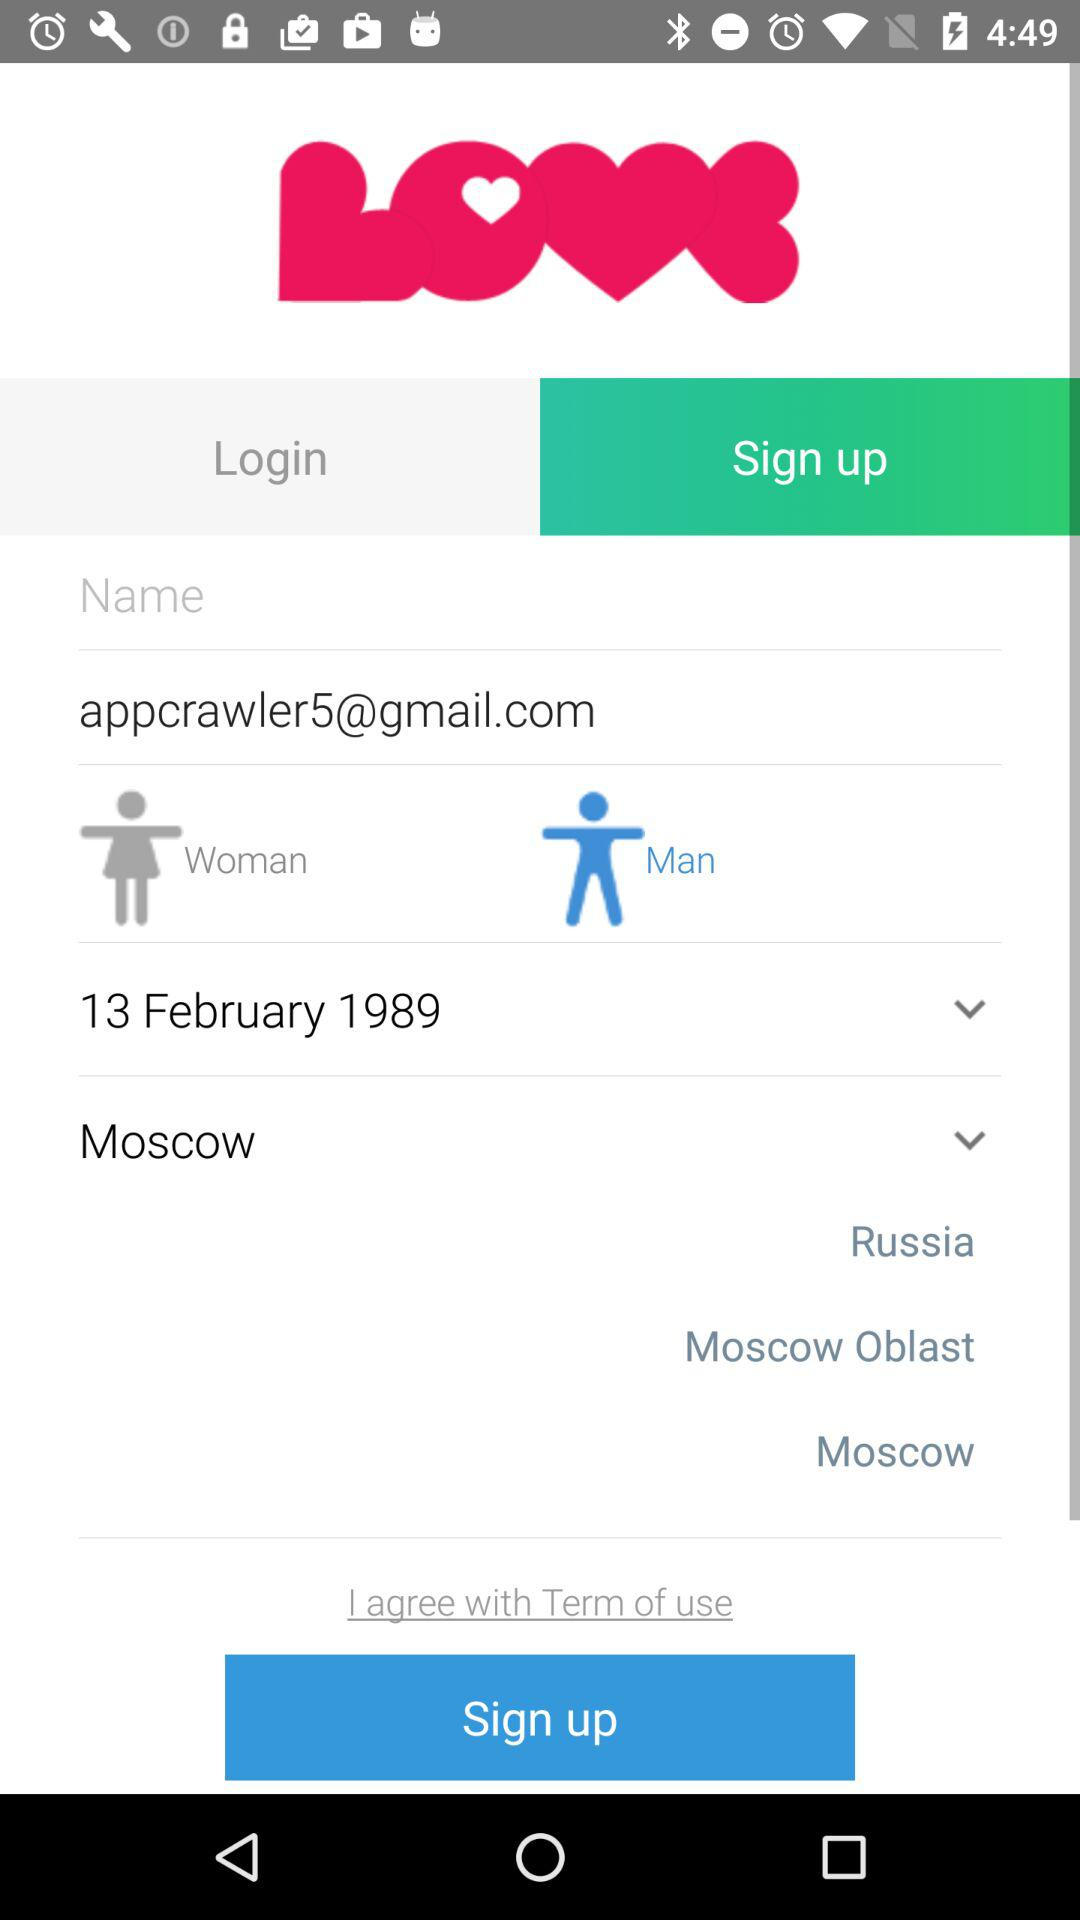Which date is selected? The selected date is February 13, 1989. 